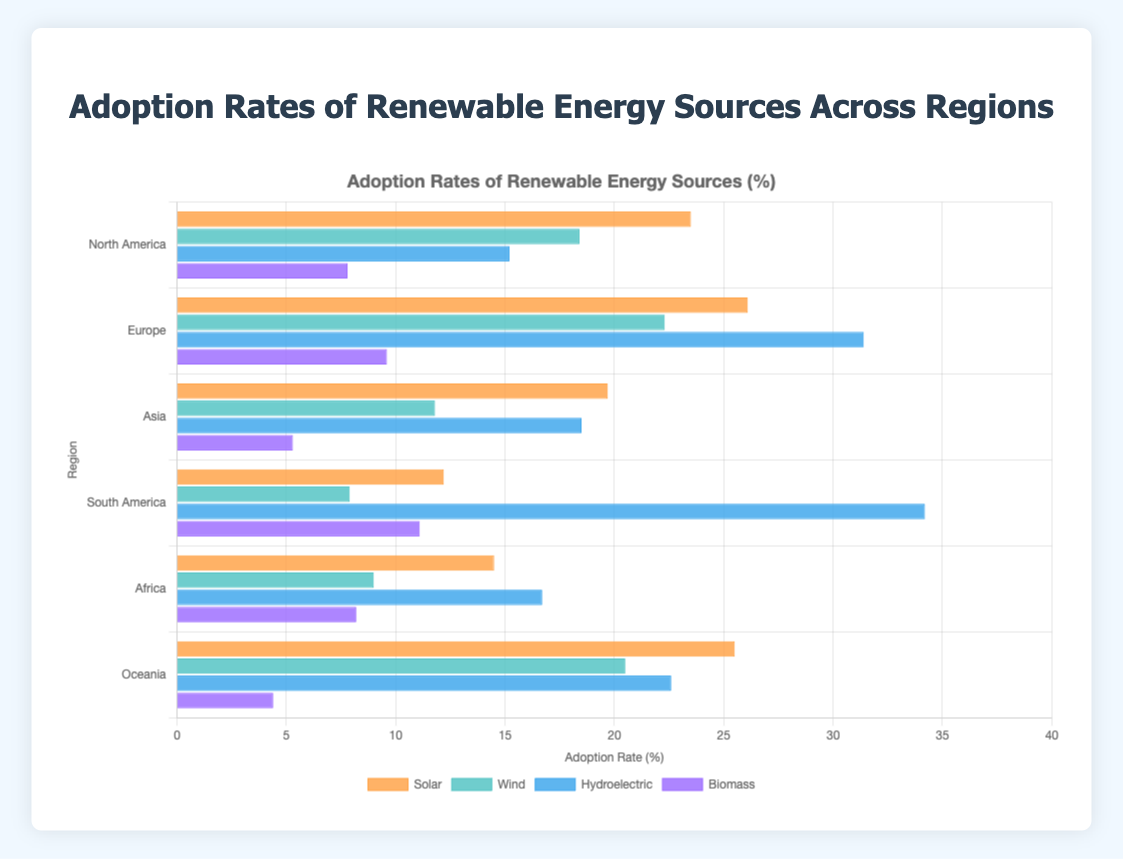Which region has the highest adoption rate for Hydroelectric energy? Looking at the bar for Hydroelectric across all regions, Europe shows the highest adoption rate with a bar length of 31.4%.
Answer: Europe Which renewable energy source has the highest adoption rate in Asia? By observing the bars for each energy source within Asia, the Hydroelectric energy source has the highest adoption rate of 18.5%.
Answer: Hydroelectric Compare the adoption rates of Solar energy between North America and Europe. The bar for Solar in North America is at 23.5%, while in Europe, it's higher at 26.1%.
Answer: Europe What is the combined adoption rate of Wind and Biomass energy in Oceania? In Oceania, Wind has an adoption rate of 20.5% and Biomass is at 4.4%. Summing these gives 20.5 + 4.4 = 24.9%.
Answer: 24.9% Which region has the least adoption of Biomass energy, and what is the rate? The Biomass bars across all regions show Oceania with the shortest bar at an adoption rate of 4.4%.
Answer: Oceania, 4.4% What is the difference in adoption rates for Solar energy between Africa and South America? The Solar adoption rate in Africa is 14.5%, while in South America it is 12.2%. The difference is 14.5 - 12.2 = 2.3%.
Answer: 2.3% What is the average adoption rate of Wind energy across all regions? The Wind adoption rates are as follows: North America (18.4%), Europe (22.3%), Asia (11.8%), South America (7.9%), Africa (9.0%), Oceania (20.5%). Summing these: 18.4 + 22.3 + 11.8 + 7.9 + 9.0 + 20.5 = 89.9. Dividing by the number of regions (6) gives 89.9 / 6 ≈ 15.0%.
Answer: 15.0% Visually, which renewable energy source has the most uniformly distributed adoption rates across all regions? By observing the bars' lengths for each energy source across all regions, Solar appears to have relatively consistent adoption rates between approximately 12.2% and 26.1%.
Answer: Solar Calculate the spread between the highest and the lowest adoption rate for Hydroelectric energy. The highest adoption rate for Hydroelectric is in South America at 34.2%, and the lowest is in North America at 15.2%. The spread is 34.2 - 15.2 = 19%.
Answer: 19% Which region has a higher Biomass adoption rate than Wind but lower than Hydroelectric? Analyzing the bars for Biomass, Wind, and Hydroelectric for each region, South America meets the criteria with Biomass at 11.1%, Wind at 7.9%, and Hydroelectric at 34.2%.
Answer: South America 